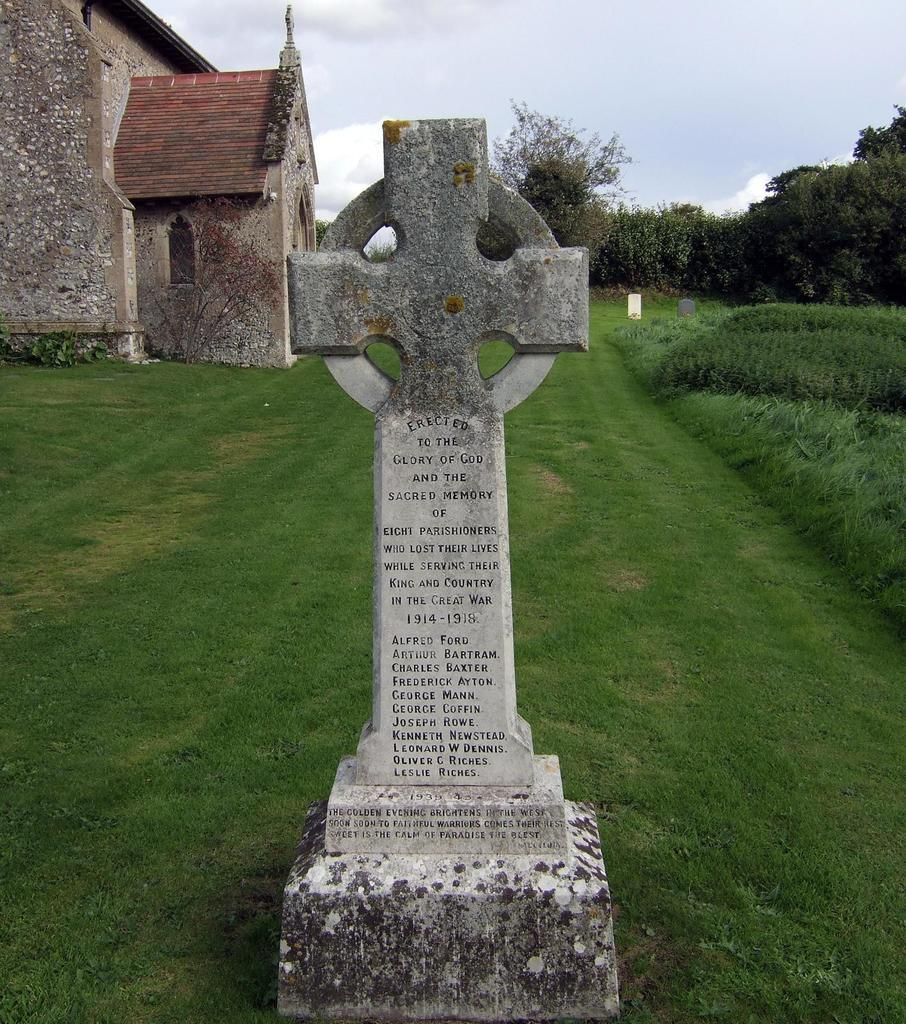What is the main subject in the middle of the image? There is a headstone in the middle of the image. What type of vegetation is visible in the background of the image? There is grass, plants, and trees in the background of the image. What type of structure can be seen in the background of the image? There is a house in the background of the image. What type of ticket is required to enter the cemetery in the image? There is no mention of a cemetery or a ticket in the image; it only shows a headstone, grass, plants, trees, and a house in the background. 